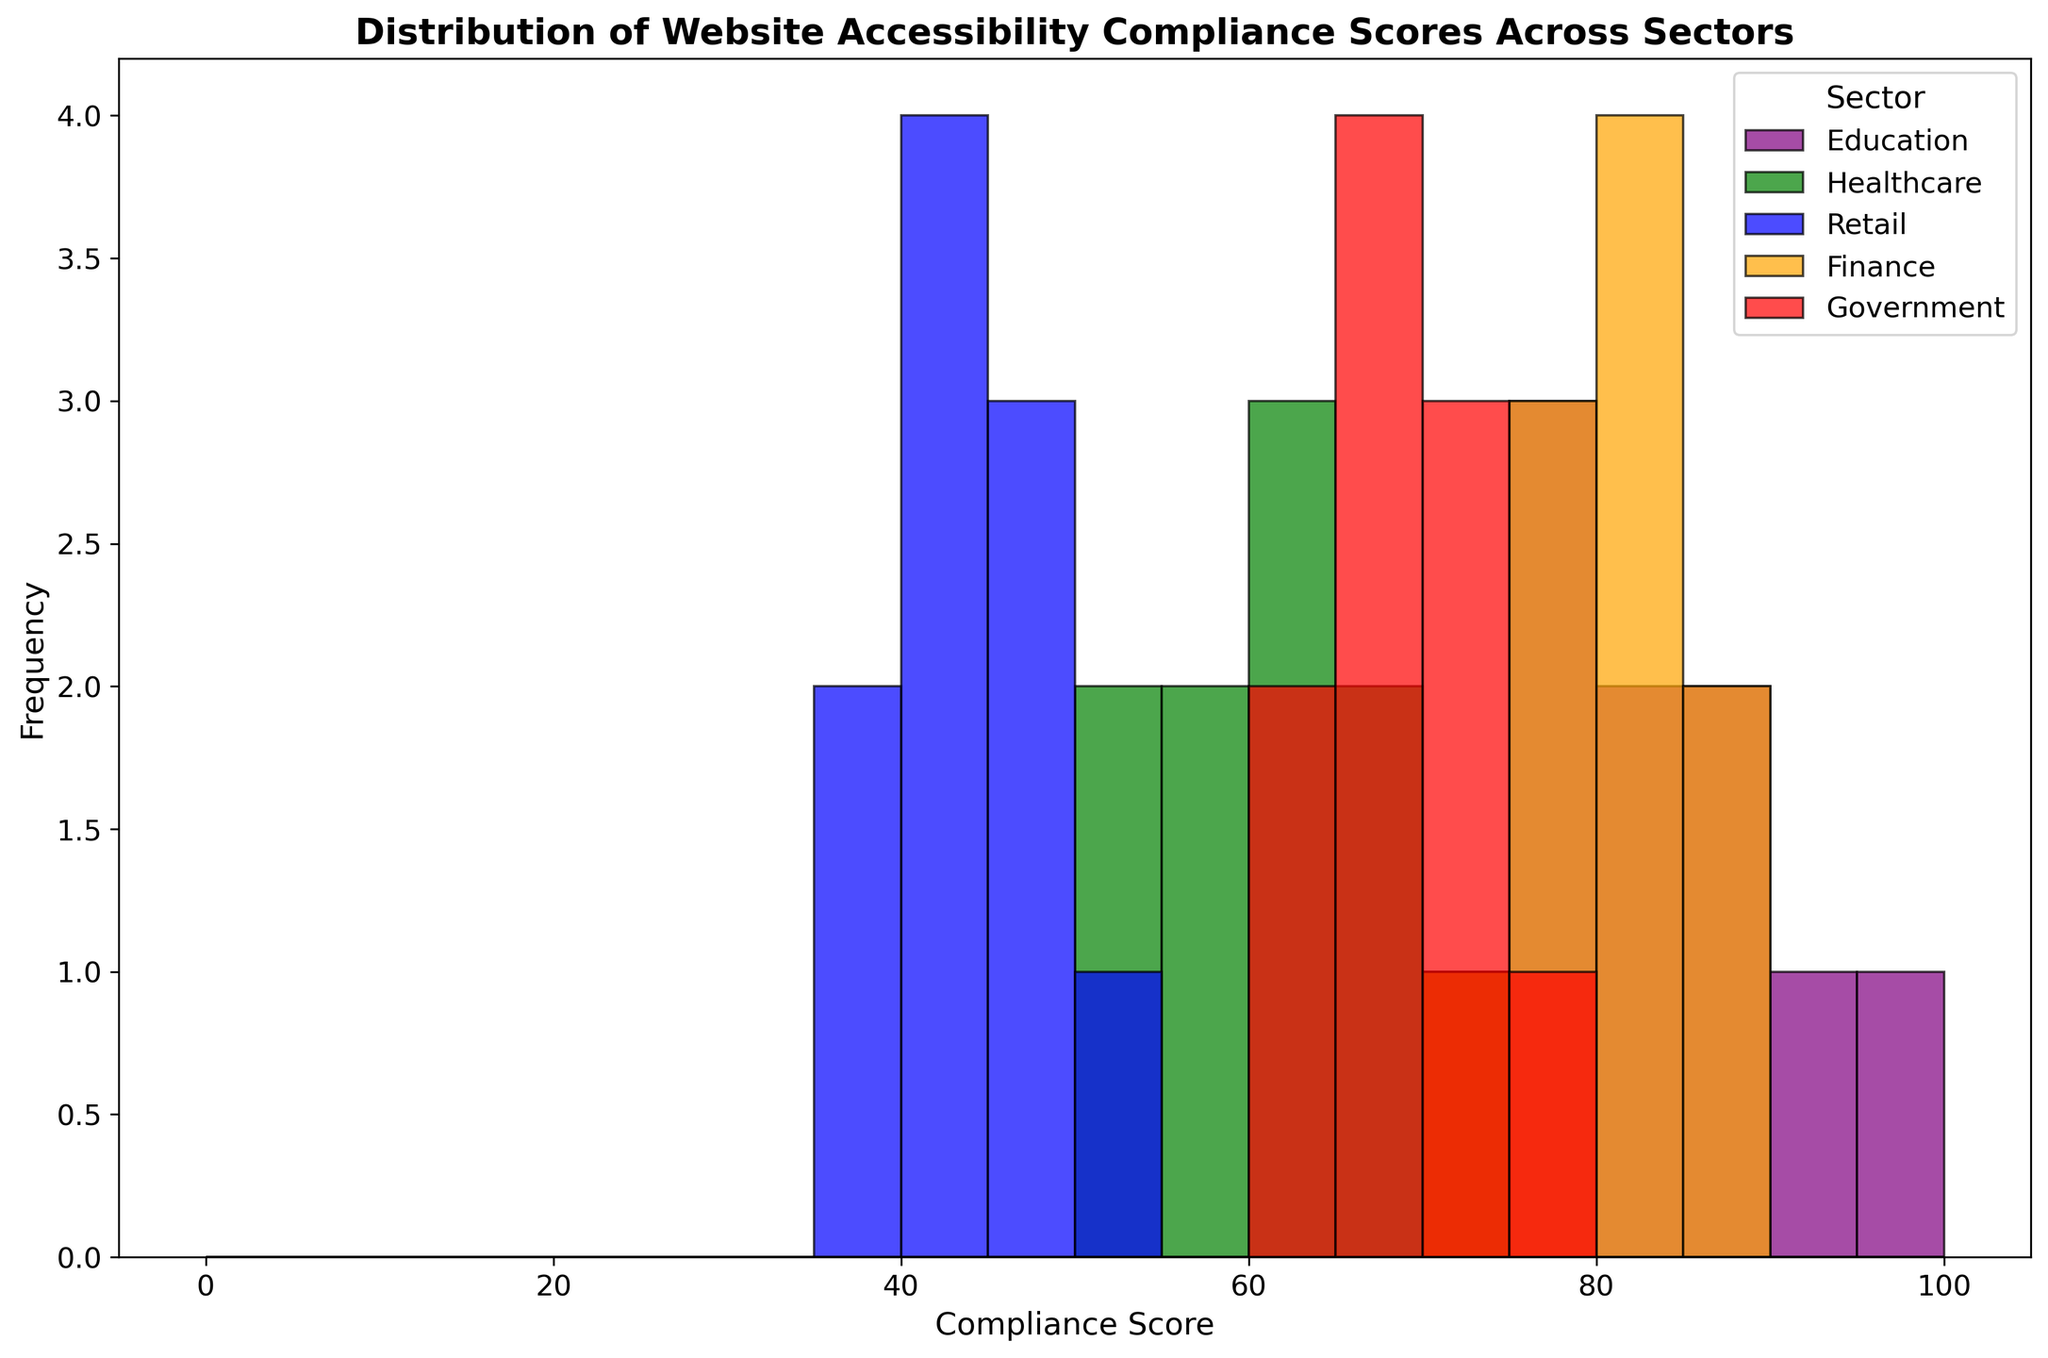What's the highest frequency of compliance scores for Education? By examining the histogram bars representing the Education sector (purple), we can find the tallest bar which corresponds to the highest frequency.
Answer: 2 Which sector has the lowest range of compliance scores? To determine the range, find the difference between the highest and lowest scores for each sector on the histogram. The sector with the smallest difference between these scores has the lowest range.
Answer: Retail How do the median compliance scores for Education and Retail compare? To find the median, sort each sector's compliance scores and identify the middle value. For Education, sort the scores and identify the 5th value (since there are 10 scores). For Retail, identify the 5th value as well (since there are also 10 scores). Compare these two values.
Answer: Education's median is higher What is the most common compliance score range for Healthcare? Look for the range (bins) with the highest frequency (tallest bar) in the histogram for the Healthcare sector (green).
Answer: 60-65 Does the Government sector have more scores in the 60-70 range or the 70-80 range? Examine the histogram bars for the Government sector (red) to count the compliance scores in the ranges 60-70 and 70-80, then compare these counts.
Answer: 60-70 range How do the frequency distributions of Healthcare and Retail compare visually? Compare the shapes and heights of the bars representing Healthcare (green) and Retail (blue) sectors on the histogram to see which has taller or more evenly spread bars.
Answer: Healthcare has more evenly spread scores Which sector demonstrates the most variability in compliance scores? Variability can be visually assessed by observing how spread out or clustered the histogram bars are for each sector. Greater spread indicates more variability.
Answer: Education What's the average compliance score in the Finance sector? The average can be calculated by summing all compliance scores in Finance and dividing by the number of scores (sum of 78, 82, 85, 76, 80, 74, 86, 81, 79, 83 divided by 10).
Answer: 80.4 Are there any sectors with scores only above 50? Identify sectors whose histogram bars are all above the 50 mark on the x-axis.
Answer: Education, Finance 